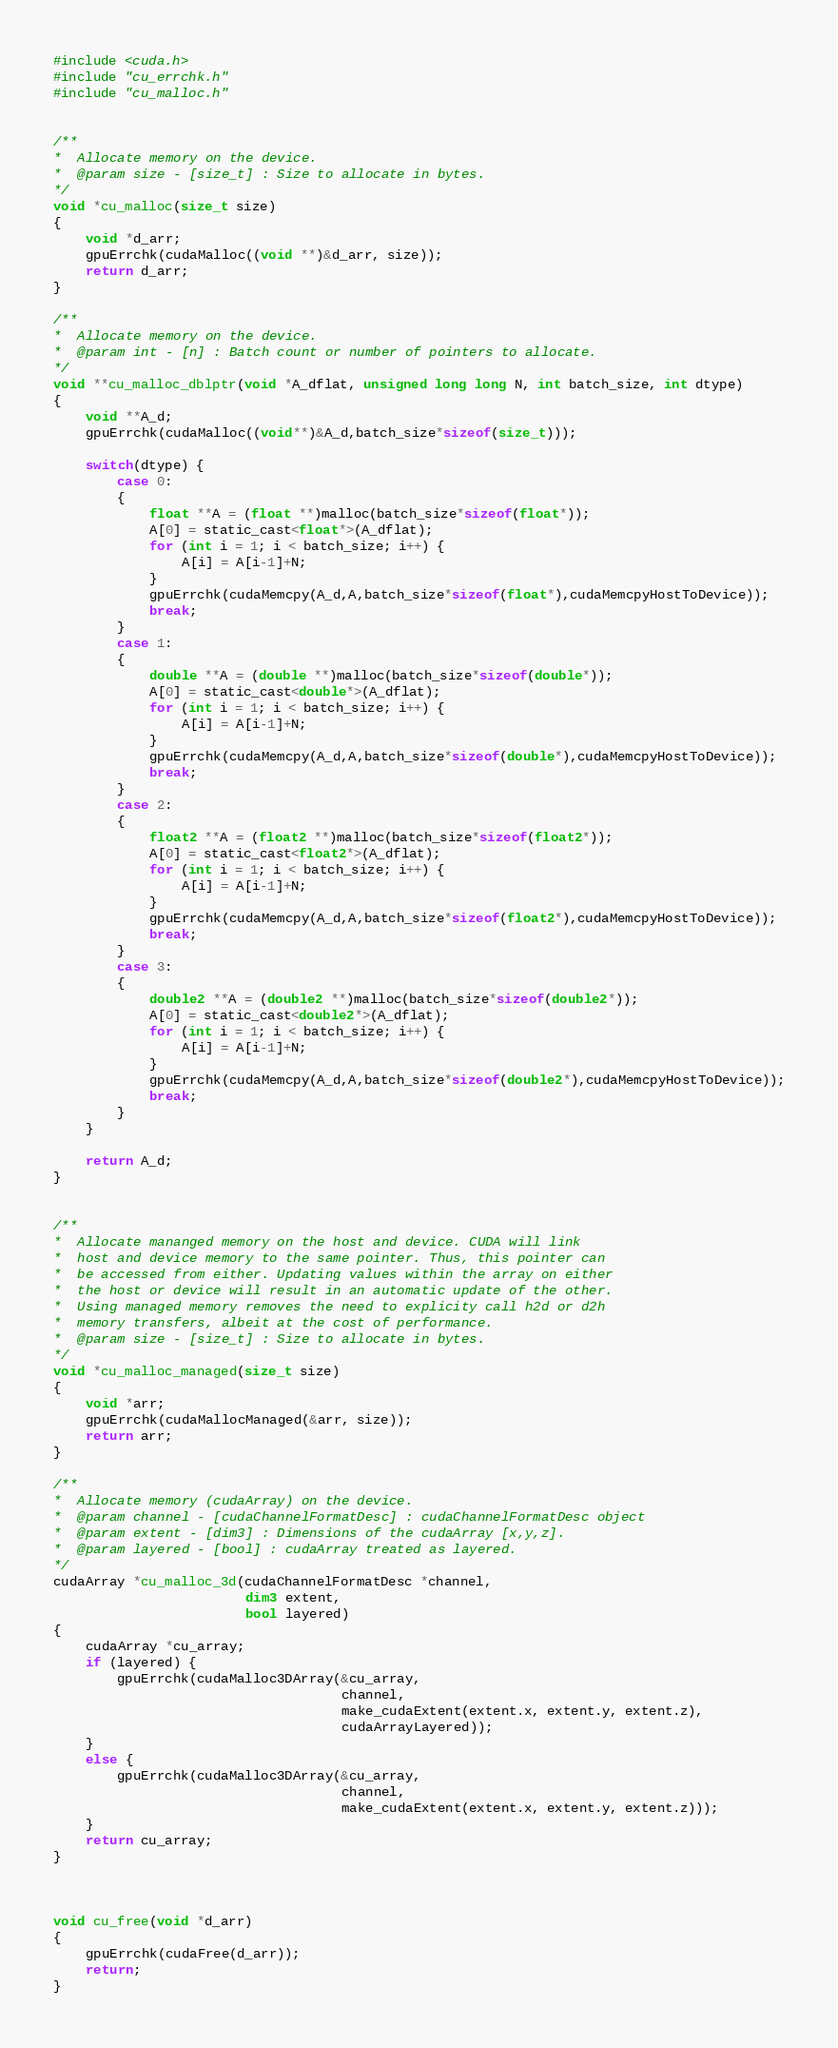Convert code to text. <code><loc_0><loc_0><loc_500><loc_500><_Cuda_>#include <cuda.h>
#include "cu_errchk.h"
#include "cu_malloc.h"


/**
*  Allocate memory on the device.
*  @param size - [size_t] : Size to allocate in bytes.
*/
void *cu_malloc(size_t size)
{
    void *d_arr;
    gpuErrchk(cudaMalloc((void **)&d_arr, size));
    return d_arr;
}

/**
*  Allocate memory on the device.
*  @param int - [n] : Batch count or number of pointers to allocate.
*/
void **cu_malloc_dblptr(void *A_dflat, unsigned long long N, int batch_size, int dtype)
{
    void **A_d;
    gpuErrchk(cudaMalloc((void**)&A_d,batch_size*sizeof(size_t)));

    switch(dtype) {
        case 0: 
        {
            float **A = (float **)malloc(batch_size*sizeof(float*));
            A[0] = static_cast<float*>(A_dflat);
            for (int i = 1; i < batch_size; i++) {
                A[i] = A[i-1]+N;
            }
            gpuErrchk(cudaMemcpy(A_d,A,batch_size*sizeof(float*),cudaMemcpyHostToDevice));
            break;
        }
        case 1: 
        {
            double **A = (double **)malloc(batch_size*sizeof(double*));
            A[0] = static_cast<double*>(A_dflat);
            for (int i = 1; i < batch_size; i++) {
                A[i] = A[i-1]+N;
            }
            gpuErrchk(cudaMemcpy(A_d,A,batch_size*sizeof(double*),cudaMemcpyHostToDevice));
            break;
        }
        case 2: 
        {
            float2 **A = (float2 **)malloc(batch_size*sizeof(float2*));
            A[0] = static_cast<float2*>(A_dflat);
            for (int i = 1; i < batch_size; i++) {
                A[i] = A[i-1]+N;
            }
            gpuErrchk(cudaMemcpy(A_d,A,batch_size*sizeof(float2*),cudaMemcpyHostToDevice));
            break;
        }
        case 3: 
        {
            double2 **A = (double2 **)malloc(batch_size*sizeof(double2*));
            A[0] = static_cast<double2*>(A_dflat);
            for (int i = 1; i < batch_size; i++) {
                A[i] = A[i-1]+N;
            }
            gpuErrchk(cudaMemcpy(A_d,A,batch_size*sizeof(double2*),cudaMemcpyHostToDevice));
            break;
        }
    }
     
    return A_d;
}


/**
*  Allocate mananged memory on the host and device. CUDA will link
*  host and device memory to the same pointer. Thus, this pointer can
*  be accessed from either. Updating values within the array on either
*  the host or device will result in an automatic update of the other.
*  Using managed memory removes the need to explicity call h2d or d2h
*  memory transfers, albeit at the cost of performance.
*  @param size - [size_t] : Size to allocate in bytes.
*/
void *cu_malloc_managed(size_t size)
{
    void *arr;
    gpuErrchk(cudaMallocManaged(&arr, size));
    return arr;
}

/**
*  Allocate memory (cudaArray) on the device.
*  @param channel - [cudaChannelFormatDesc] : cudaChannelFormatDesc object
*  @param extent - [dim3] : Dimensions of the cudaArray [x,y,z].
*  @param layered - [bool] : cudaArray treated as layered.
*/
cudaArray *cu_malloc_3d(cudaChannelFormatDesc *channel,
                        dim3 extent,
                        bool layered)
{
    cudaArray *cu_array;
    if (layered) {
        gpuErrchk(cudaMalloc3DArray(&cu_array,
                                    channel,
                                    make_cudaExtent(extent.x, extent.y, extent.z),
                                    cudaArrayLayered));
    }
    else {
        gpuErrchk(cudaMalloc3DArray(&cu_array,
                                    channel,
                                    make_cudaExtent(extent.x, extent.y, extent.z)));
    }
    return cu_array;
}



void cu_free(void *d_arr)
{
    gpuErrchk(cudaFree(d_arr));
    return;
}
</code> 